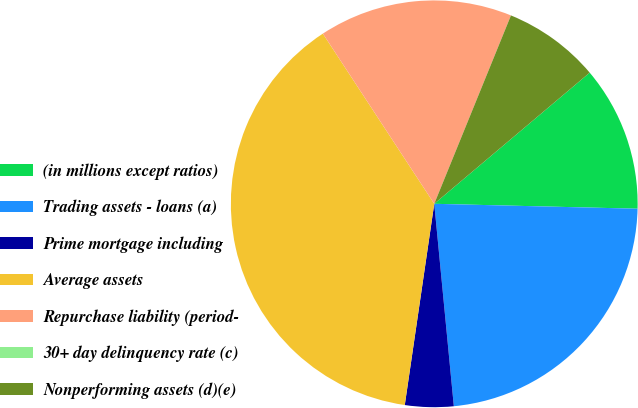Convert chart to OTSL. <chart><loc_0><loc_0><loc_500><loc_500><pie_chart><fcel>(in millions except ratios)<fcel>Trading assets - loans (a)<fcel>Prime mortgage including<fcel>Average assets<fcel>Repurchase liability (period-<fcel>30+ day delinquency rate (c)<fcel>Nonperforming assets (d)(e)<nl><fcel>11.54%<fcel>23.08%<fcel>3.85%<fcel>38.46%<fcel>15.38%<fcel>0.0%<fcel>7.69%<nl></chart> 